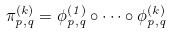Convert formula to latex. <formula><loc_0><loc_0><loc_500><loc_500>\pi _ { p , q } ^ { ( k ) } = \phi _ { p , q } ^ { ( 1 ) } \circ \dots \circ \phi _ { p , q } ^ { ( k ) }</formula> 